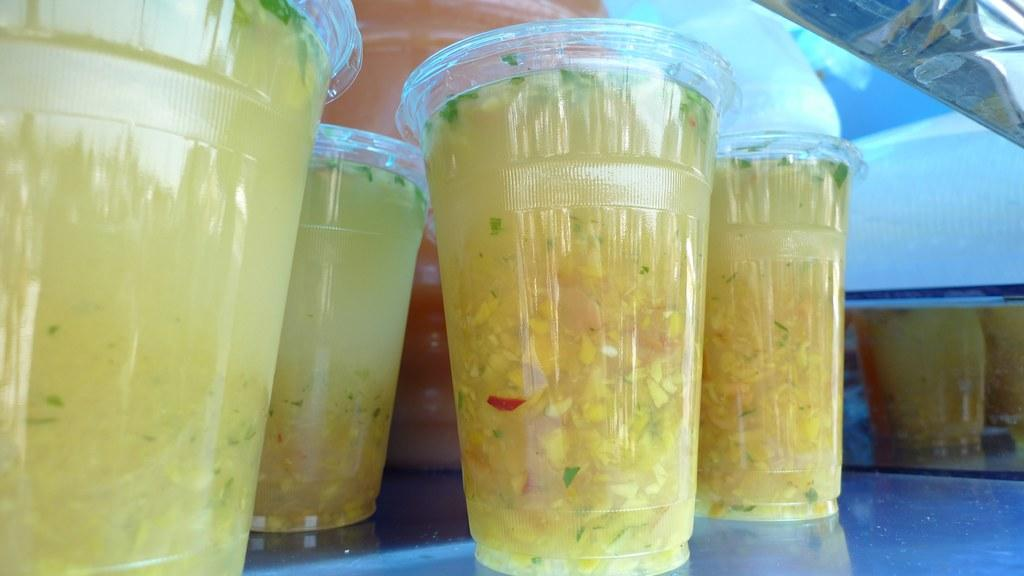What is contained in the glasses that are visible in the image? There are glasses with liquid in the image. Where are the glasses placed in the image? The glasses are on a glass platform in the image. What other objects can be seen in the image besides the glasses? There are other objects present in the image. Is the boy playing in the rain on the land visible in the image? There is no boy, rain, or land present in the image; it only features glasses with liquid on a glass platform. 